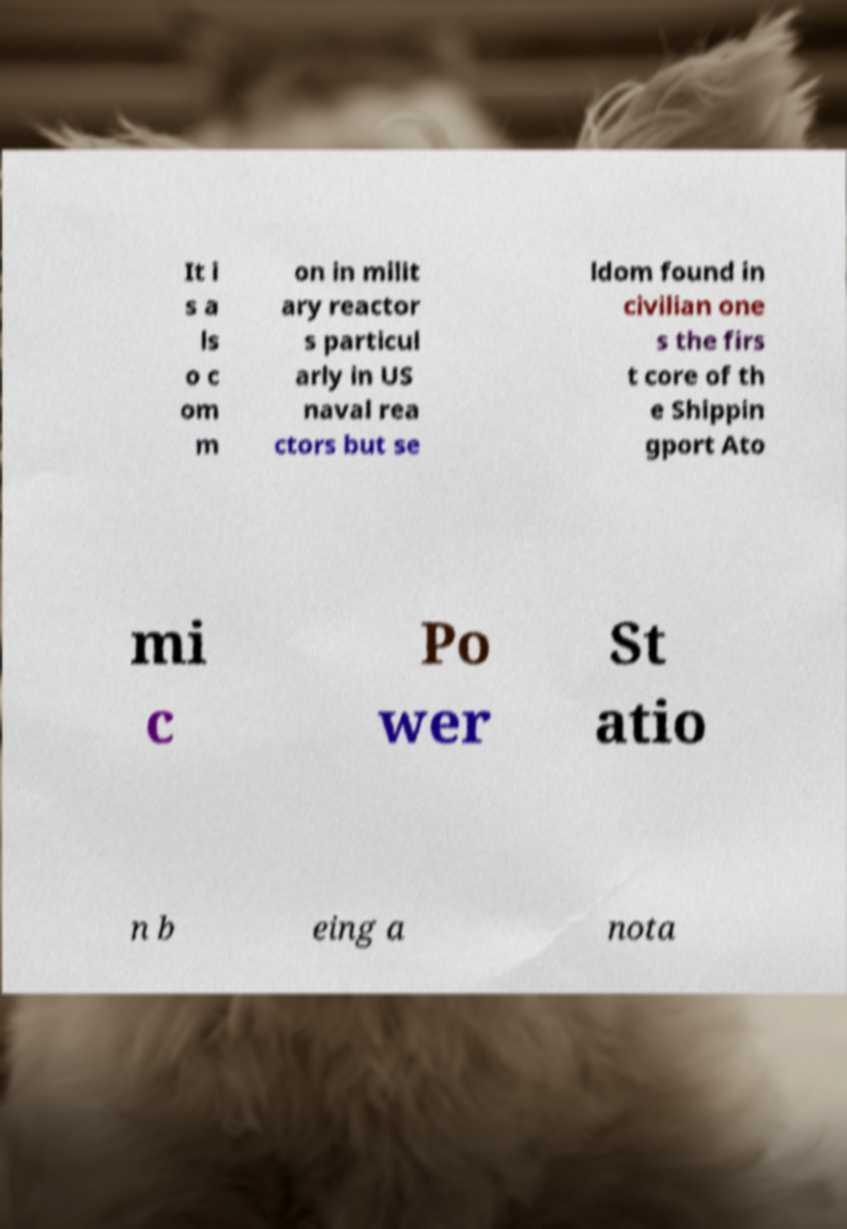Can you read and provide the text displayed in the image?This photo seems to have some interesting text. Can you extract and type it out for me? It i s a ls o c om m on in milit ary reactor s particul arly in US naval rea ctors but se ldom found in civilian one s the firs t core of th e Shippin gport Ato mi c Po wer St atio n b eing a nota 